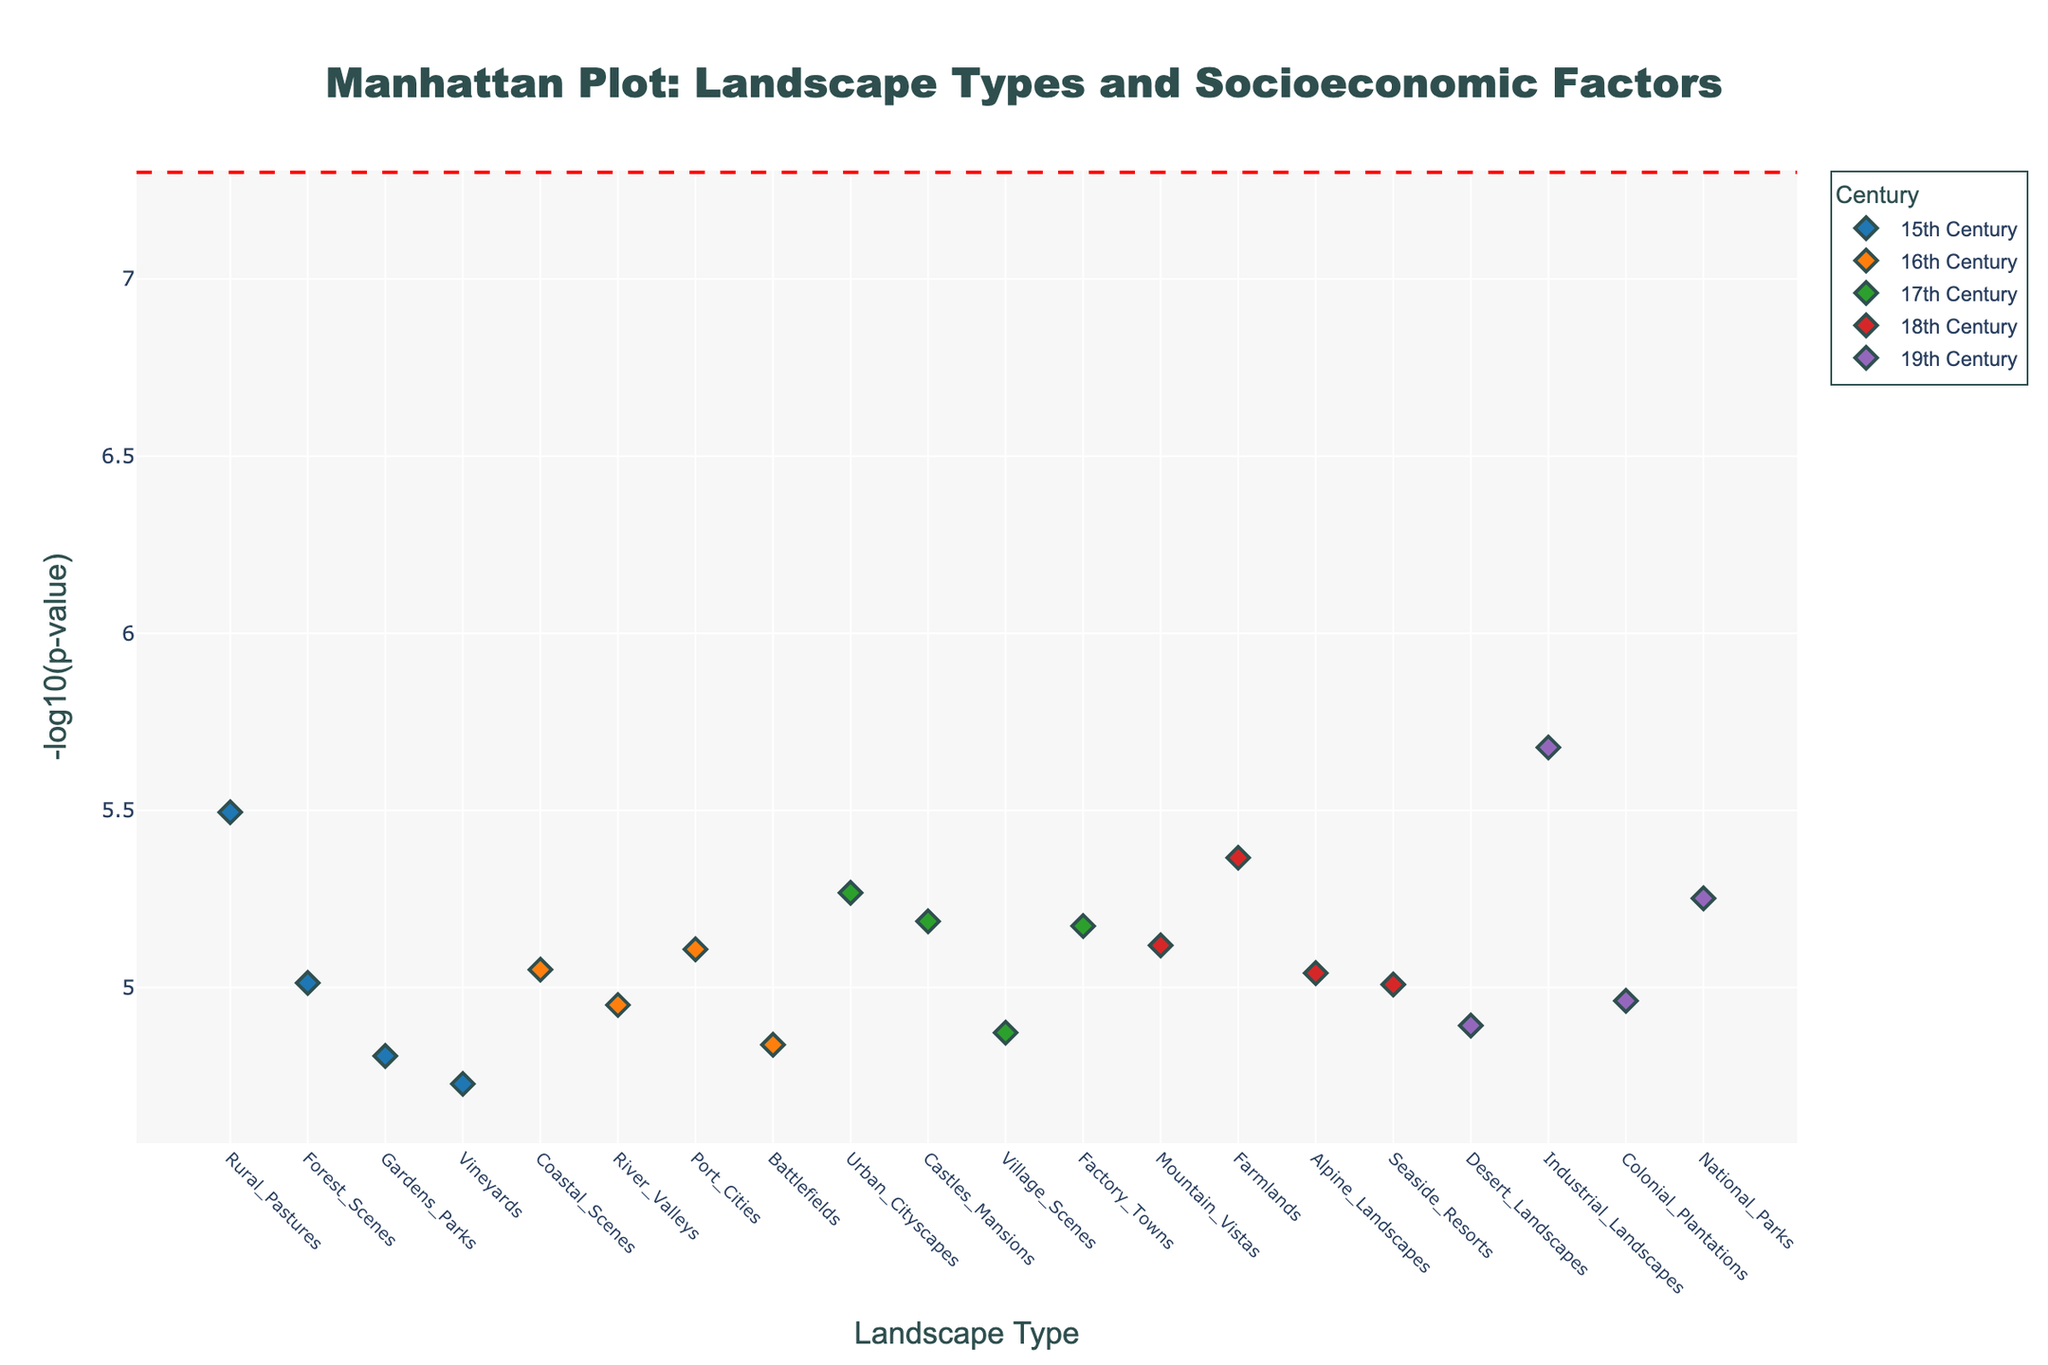what is the title of the plot? The title of the plot is generally mentioned at the top of the figure in a larger and bold font. It provides a summary of what the figure represents. The title here is "Manhattan Plot: Landscape Types and Socioeconomic Factors".
Answer: Manhattan Plot: Landscape Types and Socioeconomic Factors which landscape type in the 19th century is related to the smallest p-value? To find this, look at the group of points colored in the shade representing the 19th century and find the one with the highest -log10(p). This is "Industrial_Landscapes", corresponding to the smallest p-value.
Answer: Industrial_Landscapes what are the larger clusters of landscape types indicating in relation to socioeconomic factors for the 18th century? Larger clusters can indicate a strong correlation between landscape types and socioeconomic factors. For the 18th century (red dots), larger clusters imply multiple landscape types such as "Mountain_Vistas", "Farmlands", and "Alpine_Landscapes" are linked to socioeconomic changes like Romanticism, Rural Exodus, and Grand Tour Tradition.
Answer: Multiple landscape types linked to Romanticism, Rural Exodus, and Grand Tour Tradition which century has the most diverse range of landscape types represented? Look at the different color groups and count the unique landscape types associated with them. The 18th century (red dots) seems to have the most diverse range of landscape types, including "Mountain_Vistas", "Farmlands", "Alpine_Landscapes", etc.
Answer: 18th century are there any landscapes with p-values above the significance threshold across all centuries? The red dashed horizontal line represents the significance threshold. We must check all points above this line. Most points lie below the threshold, indicating significant correlations. None appear above it.
Answer: None which socioeconomic factor has the lowest -log10(p-value) across all data points, and what is its associated landscape and century? To identify this, find the highest y-axis point representing -log10(p-value). The point with the lowest p-value has the highest -log10(p-value). For "Industrialization" related to "Industrial_Landscapes" in the 19th century.
Answer: Industrialization, Industrial_Landscapes, 19th century is there a trend in landscape types becoming more urban or rural across different centuries? To analyze this, compare early centuries (15th, 16th) predominantly featuring "Rural_Pastures", "Coastal_Scenes" with later centuries like the 18th and 19th showing more "Industrial_Landscapes", "Factory_Towns". There is a trend from rural to more urban landscapes over time.
Answer: Trend from rural to urban landscapes what is the significance threshold line represented in the plot, and why is it important? The red dashed horizontal line stands for the -log10 of the significance threshold. It shows the level below which p-values are considered significant, highlighting correlations between landscape types and socioeconomic factors. This helps identify statistically significant points.
Answer: -log10(5e-8), to show significance 